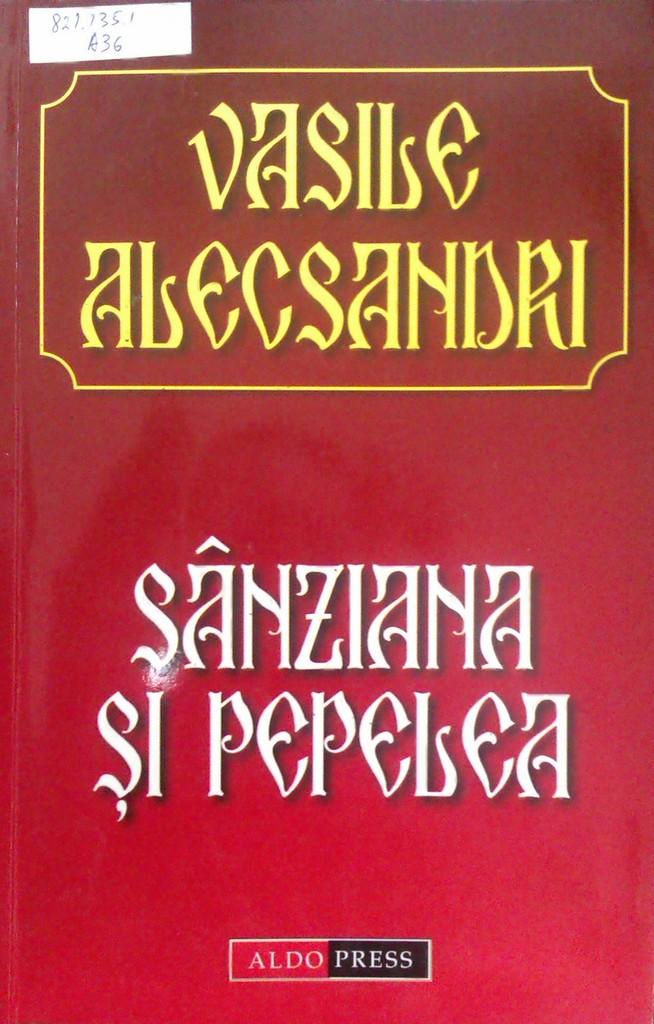What is the title of the book?
Provide a short and direct response. Sanziana si pepelea. Who is publisher?
Keep it short and to the point. Aldo press. 